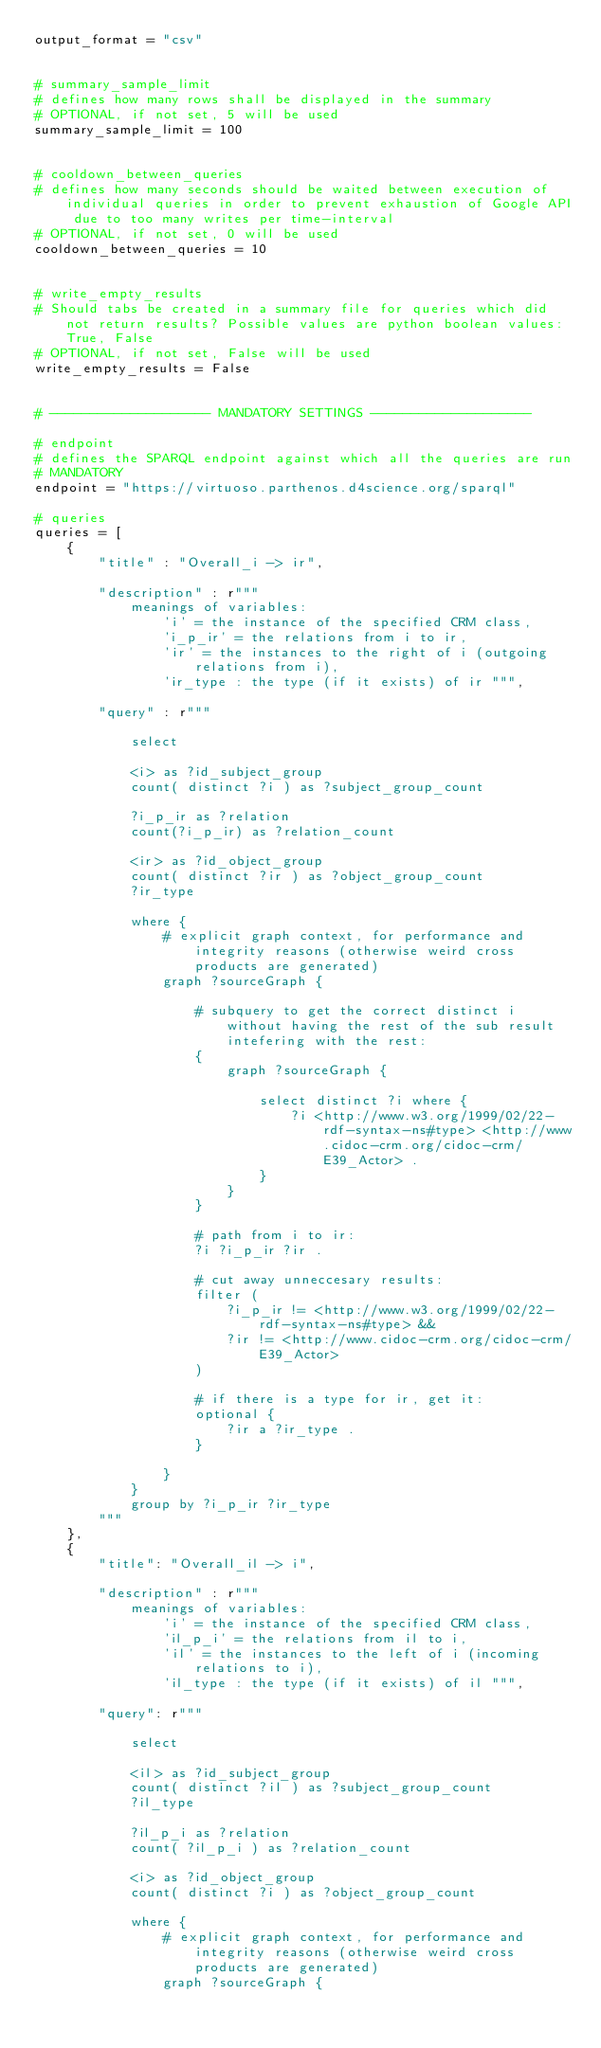<code> <loc_0><loc_0><loc_500><loc_500><_Python_>output_format = "csv"


# summary_sample_limit
# defines how many rows shall be displayed in the summary
# OPTIONAL, if not set, 5 will be used
summary_sample_limit = 100


# cooldown_between_queries
# defines how many seconds should be waited between execution of individual queries in order to prevent exhaustion of Google API due to too many writes per time-interval
# OPTIONAL, if not set, 0 will be used
cooldown_between_queries = 10


# write_empty_results
# Should tabs be created in a summary file for queries which did not return results? Possible values are python boolean values: True, False
# OPTIONAL, if not set, False will be used
write_empty_results = False


# -------------------- MANDATORY SETTINGS -------------------- 

# endpoint
# defines the SPARQL endpoint against which all the queries are run
# MANDATORY
endpoint = "https://virtuoso.parthenos.d4science.org/sparql"

# queries
queries = [
    {
        "title" : "Overall_i -> ir",
        
        "description" : r"""
            meanings of variables: 
                'i' = the instance of the specified CRM class, 
                'i_p_ir' = the relations from i to ir, 
                'ir' = the instances to the right of i (outgoing relations from i), 
                'ir_type : the type (if it exists) of ir """,
                
        "query" : r"""
            
            select 
            
            <i> as ?id_subject_group
            count( distinct ?i ) as ?subject_group_count
            
            ?i_p_ir as ?relation
            count(?i_p_ir) as ?relation_count
            
            <ir> as ?id_object_group
            count( distinct ?ir ) as ?object_group_count
            ?ir_type
            
            where {
                # explicit graph context, for performance and integrity reasons (otherwise weird cross products are generated)
                graph ?sourceGraph {
            
                    # subquery to get the correct distinct i without having the rest of the sub result intefering with the rest:
                    {
                        graph ?sourceGraph {

                            select distinct ?i where {
                                ?i <http://www.w3.org/1999/02/22-rdf-syntax-ns#type> <http://www.cidoc-crm.org/cidoc-crm/E39_Actor> .
                            } 
                        }
                    }
                    
                    # path from i to ir:
                    ?i ?i_p_ir ?ir .
                    
                    # cut away unneccesary results:
                    filter (
                        ?i_p_ir != <http://www.w3.org/1999/02/22-rdf-syntax-ns#type> && 
                        ?ir != <http://www.cidoc-crm.org/cidoc-crm/E39_Actor>
                    )
                    
                    # if there is a type for ir, get it:
                    optional {
                        ?ir a ?ir_type .
                    }
                    
                }
            }
            group by ?i_p_ir ?ir_type
        """
    },
    {
        "title": "Overall_il -> i",
        
        "description" : r"""
            meanings of variables: 
                'i' = the instance of the specified CRM class, 
                'il_p_i' = the relations from il to i, 
                'il' = the instances to the left of i (incoming relations to i), 
                'il_type : the type (if it exists) of il """,
                
        "query": r"""

            select 

            <il> as ?id_subject_group
            count( distinct ?il ) as ?subject_group_count
            ?il_type

            ?il_p_i as ?relation
            count( ?il_p_i ) as ?relation_count

            <i> as ?id_object_group
            count( distinct ?i ) as ?object_group_count

            where {
                # explicit graph context, for performance and integrity reasons (otherwise weird cross products are generated)
                graph ?sourceGraph {
</code> 